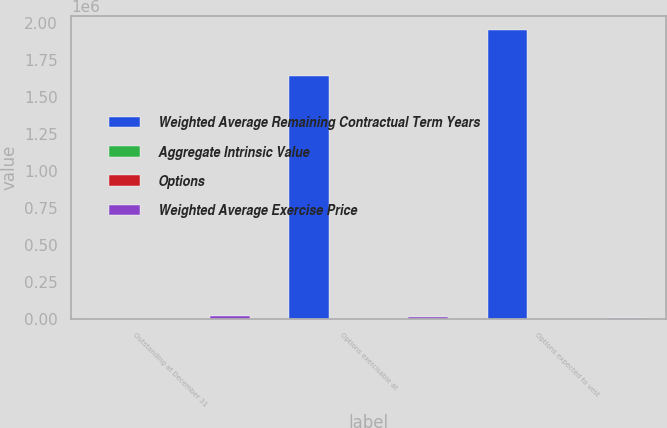<chart> <loc_0><loc_0><loc_500><loc_500><stacked_bar_chart><ecel><fcel>Outstanding at December 31<fcel>Options exercisable at<fcel>Options expected to vest<nl><fcel>Weighted Average Remaining Contractual Term Years<fcel>36.73<fcel>1.6371e+06<fcel>1.94805e+06<nl><fcel>Aggregate Intrinsic Value<fcel>34.41<fcel>31.53<fcel>36.73<nl><fcel>Options<fcel>7.28<fcel>5.69<fcel>8.55<nl><fcel>Weighted Average Exercise Price<fcel>16373<fcel>12806<fcel>3432<nl></chart> 